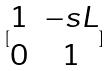Convert formula to latex. <formula><loc_0><loc_0><loc_500><loc_500>[ \begin{matrix} 1 & - s L \\ 0 & 1 \end{matrix} ]</formula> 